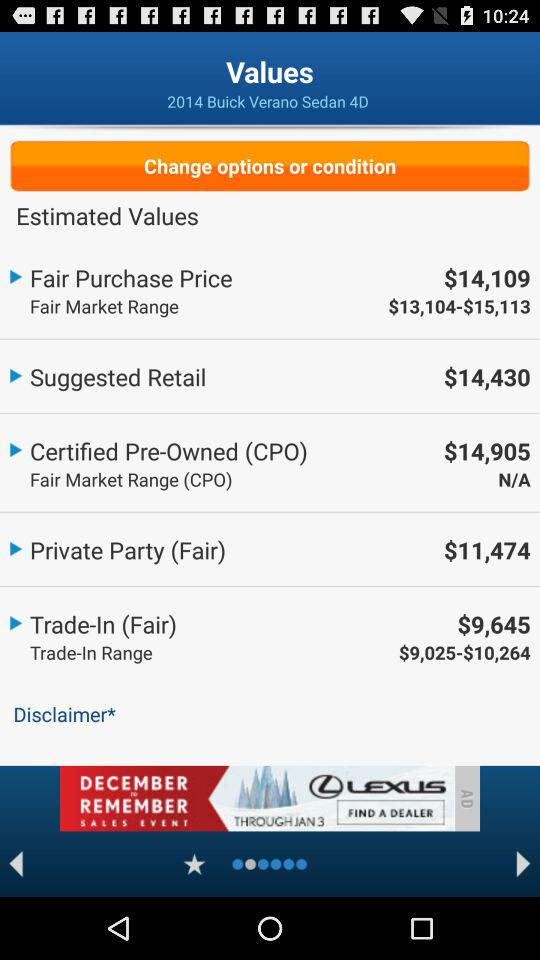What is the fair purchase price? The price is $14,109. 